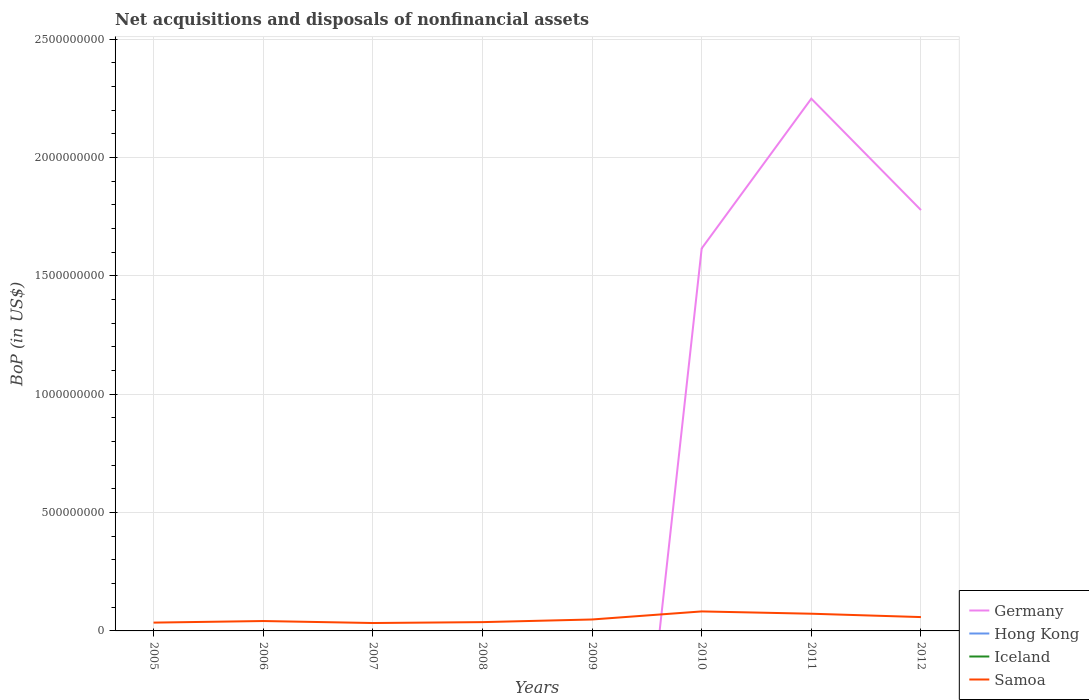How many different coloured lines are there?
Ensure brevity in your answer.  2. Does the line corresponding to Hong Kong intersect with the line corresponding to Germany?
Give a very brief answer. Yes. What is the total Balance of Payments in Samoa in the graph?
Give a very brief answer. -1.49e+07. What is the difference between the highest and the second highest Balance of Payments in Samoa?
Provide a short and direct response. 4.90e+07. How many lines are there?
Your answer should be compact. 2. How many years are there in the graph?
Give a very brief answer. 8. What is the difference between two consecutive major ticks on the Y-axis?
Your answer should be very brief. 5.00e+08. Does the graph contain any zero values?
Offer a terse response. Yes. Does the graph contain grids?
Give a very brief answer. Yes. Where does the legend appear in the graph?
Provide a short and direct response. Bottom right. How are the legend labels stacked?
Give a very brief answer. Vertical. What is the title of the graph?
Give a very brief answer. Net acquisitions and disposals of nonfinancial assets. Does "Belarus" appear as one of the legend labels in the graph?
Your response must be concise. No. What is the label or title of the X-axis?
Keep it short and to the point. Years. What is the label or title of the Y-axis?
Ensure brevity in your answer.  BoP (in US$). What is the BoP (in US$) in Hong Kong in 2005?
Give a very brief answer. 0. What is the BoP (in US$) of Iceland in 2005?
Your response must be concise. 0. What is the BoP (in US$) in Samoa in 2005?
Give a very brief answer. 3.51e+07. What is the BoP (in US$) in Iceland in 2006?
Offer a terse response. 0. What is the BoP (in US$) in Samoa in 2006?
Make the answer very short. 4.18e+07. What is the BoP (in US$) of Hong Kong in 2007?
Your response must be concise. 0. What is the BoP (in US$) of Samoa in 2007?
Provide a short and direct response. 3.34e+07. What is the BoP (in US$) of Germany in 2008?
Offer a terse response. 0. What is the BoP (in US$) in Hong Kong in 2008?
Your response must be concise. 0. What is the BoP (in US$) of Samoa in 2008?
Offer a terse response. 3.72e+07. What is the BoP (in US$) in Germany in 2009?
Your answer should be very brief. 0. What is the BoP (in US$) in Samoa in 2009?
Provide a short and direct response. 4.83e+07. What is the BoP (in US$) in Germany in 2010?
Provide a short and direct response. 1.62e+09. What is the BoP (in US$) of Iceland in 2010?
Make the answer very short. 0. What is the BoP (in US$) of Samoa in 2010?
Your response must be concise. 8.24e+07. What is the BoP (in US$) in Germany in 2011?
Provide a succinct answer. 2.25e+09. What is the BoP (in US$) in Iceland in 2011?
Your answer should be very brief. 0. What is the BoP (in US$) in Samoa in 2011?
Ensure brevity in your answer.  7.27e+07. What is the BoP (in US$) in Germany in 2012?
Keep it short and to the point. 1.78e+09. What is the BoP (in US$) in Samoa in 2012?
Make the answer very short. 5.84e+07. Across all years, what is the maximum BoP (in US$) of Germany?
Provide a succinct answer. 2.25e+09. Across all years, what is the maximum BoP (in US$) in Samoa?
Provide a short and direct response. 8.24e+07. Across all years, what is the minimum BoP (in US$) in Germany?
Make the answer very short. 0. Across all years, what is the minimum BoP (in US$) in Samoa?
Offer a terse response. 3.34e+07. What is the total BoP (in US$) in Germany in the graph?
Provide a succinct answer. 5.64e+09. What is the total BoP (in US$) in Iceland in the graph?
Your answer should be compact. 0. What is the total BoP (in US$) of Samoa in the graph?
Provide a short and direct response. 4.09e+08. What is the difference between the BoP (in US$) of Samoa in 2005 and that in 2006?
Provide a succinct answer. -6.65e+06. What is the difference between the BoP (in US$) in Samoa in 2005 and that in 2007?
Ensure brevity in your answer.  1.72e+06. What is the difference between the BoP (in US$) in Samoa in 2005 and that in 2008?
Keep it short and to the point. -2.09e+06. What is the difference between the BoP (in US$) in Samoa in 2005 and that in 2009?
Keep it short and to the point. -1.32e+07. What is the difference between the BoP (in US$) of Samoa in 2005 and that in 2010?
Make the answer very short. -4.73e+07. What is the difference between the BoP (in US$) in Samoa in 2005 and that in 2011?
Offer a very short reply. -3.76e+07. What is the difference between the BoP (in US$) of Samoa in 2005 and that in 2012?
Your answer should be compact. -2.33e+07. What is the difference between the BoP (in US$) of Samoa in 2006 and that in 2007?
Your answer should be compact. 8.37e+06. What is the difference between the BoP (in US$) in Samoa in 2006 and that in 2008?
Your answer should be compact. 4.56e+06. What is the difference between the BoP (in US$) in Samoa in 2006 and that in 2009?
Provide a short and direct response. -6.56e+06. What is the difference between the BoP (in US$) in Samoa in 2006 and that in 2010?
Make the answer very short. -4.06e+07. What is the difference between the BoP (in US$) in Samoa in 2006 and that in 2011?
Give a very brief answer. -3.09e+07. What is the difference between the BoP (in US$) of Samoa in 2006 and that in 2012?
Keep it short and to the point. -1.67e+07. What is the difference between the BoP (in US$) of Samoa in 2007 and that in 2008?
Your response must be concise. -3.81e+06. What is the difference between the BoP (in US$) in Samoa in 2007 and that in 2009?
Your answer should be compact. -1.49e+07. What is the difference between the BoP (in US$) in Samoa in 2007 and that in 2010?
Make the answer very short. -4.90e+07. What is the difference between the BoP (in US$) of Samoa in 2007 and that in 2011?
Keep it short and to the point. -3.93e+07. What is the difference between the BoP (in US$) of Samoa in 2007 and that in 2012?
Your answer should be compact. -2.51e+07. What is the difference between the BoP (in US$) of Samoa in 2008 and that in 2009?
Your response must be concise. -1.11e+07. What is the difference between the BoP (in US$) of Samoa in 2008 and that in 2010?
Provide a short and direct response. -4.52e+07. What is the difference between the BoP (in US$) in Samoa in 2008 and that in 2011?
Give a very brief answer. -3.55e+07. What is the difference between the BoP (in US$) in Samoa in 2008 and that in 2012?
Ensure brevity in your answer.  -2.13e+07. What is the difference between the BoP (in US$) in Samoa in 2009 and that in 2010?
Give a very brief answer. -3.41e+07. What is the difference between the BoP (in US$) of Samoa in 2009 and that in 2011?
Make the answer very short. -2.44e+07. What is the difference between the BoP (in US$) in Samoa in 2009 and that in 2012?
Ensure brevity in your answer.  -1.01e+07. What is the difference between the BoP (in US$) in Germany in 2010 and that in 2011?
Give a very brief answer. -6.33e+08. What is the difference between the BoP (in US$) in Samoa in 2010 and that in 2011?
Give a very brief answer. 9.68e+06. What is the difference between the BoP (in US$) in Germany in 2010 and that in 2012?
Keep it short and to the point. -1.62e+08. What is the difference between the BoP (in US$) in Samoa in 2010 and that in 2012?
Offer a terse response. 2.39e+07. What is the difference between the BoP (in US$) of Germany in 2011 and that in 2012?
Your answer should be very brief. 4.70e+08. What is the difference between the BoP (in US$) of Samoa in 2011 and that in 2012?
Make the answer very short. 1.42e+07. What is the difference between the BoP (in US$) of Germany in 2010 and the BoP (in US$) of Samoa in 2011?
Ensure brevity in your answer.  1.54e+09. What is the difference between the BoP (in US$) in Germany in 2010 and the BoP (in US$) in Samoa in 2012?
Your answer should be very brief. 1.56e+09. What is the difference between the BoP (in US$) in Germany in 2011 and the BoP (in US$) in Samoa in 2012?
Provide a succinct answer. 2.19e+09. What is the average BoP (in US$) of Germany per year?
Your answer should be compact. 7.05e+08. What is the average BoP (in US$) of Hong Kong per year?
Your answer should be very brief. 0. What is the average BoP (in US$) in Iceland per year?
Provide a short and direct response. 0. What is the average BoP (in US$) of Samoa per year?
Your response must be concise. 5.12e+07. In the year 2010, what is the difference between the BoP (in US$) of Germany and BoP (in US$) of Samoa?
Ensure brevity in your answer.  1.53e+09. In the year 2011, what is the difference between the BoP (in US$) in Germany and BoP (in US$) in Samoa?
Offer a terse response. 2.18e+09. In the year 2012, what is the difference between the BoP (in US$) of Germany and BoP (in US$) of Samoa?
Provide a short and direct response. 1.72e+09. What is the ratio of the BoP (in US$) of Samoa in 2005 to that in 2006?
Your answer should be very brief. 0.84. What is the ratio of the BoP (in US$) in Samoa in 2005 to that in 2007?
Your answer should be very brief. 1.05. What is the ratio of the BoP (in US$) in Samoa in 2005 to that in 2008?
Offer a terse response. 0.94. What is the ratio of the BoP (in US$) of Samoa in 2005 to that in 2009?
Give a very brief answer. 0.73. What is the ratio of the BoP (in US$) of Samoa in 2005 to that in 2010?
Offer a very short reply. 0.43. What is the ratio of the BoP (in US$) of Samoa in 2005 to that in 2011?
Your answer should be very brief. 0.48. What is the ratio of the BoP (in US$) of Samoa in 2005 to that in 2012?
Give a very brief answer. 0.6. What is the ratio of the BoP (in US$) of Samoa in 2006 to that in 2007?
Provide a short and direct response. 1.25. What is the ratio of the BoP (in US$) of Samoa in 2006 to that in 2008?
Offer a very short reply. 1.12. What is the ratio of the BoP (in US$) in Samoa in 2006 to that in 2009?
Make the answer very short. 0.86. What is the ratio of the BoP (in US$) in Samoa in 2006 to that in 2010?
Ensure brevity in your answer.  0.51. What is the ratio of the BoP (in US$) of Samoa in 2006 to that in 2011?
Provide a succinct answer. 0.57. What is the ratio of the BoP (in US$) of Samoa in 2006 to that in 2012?
Make the answer very short. 0.71. What is the ratio of the BoP (in US$) in Samoa in 2007 to that in 2008?
Your answer should be very brief. 0.9. What is the ratio of the BoP (in US$) of Samoa in 2007 to that in 2009?
Your answer should be very brief. 0.69. What is the ratio of the BoP (in US$) in Samoa in 2007 to that in 2010?
Give a very brief answer. 0.41. What is the ratio of the BoP (in US$) of Samoa in 2007 to that in 2011?
Give a very brief answer. 0.46. What is the ratio of the BoP (in US$) of Samoa in 2007 to that in 2012?
Your answer should be very brief. 0.57. What is the ratio of the BoP (in US$) of Samoa in 2008 to that in 2009?
Offer a very short reply. 0.77. What is the ratio of the BoP (in US$) of Samoa in 2008 to that in 2010?
Offer a terse response. 0.45. What is the ratio of the BoP (in US$) of Samoa in 2008 to that in 2011?
Your answer should be very brief. 0.51. What is the ratio of the BoP (in US$) in Samoa in 2008 to that in 2012?
Provide a succinct answer. 0.64. What is the ratio of the BoP (in US$) in Samoa in 2009 to that in 2010?
Give a very brief answer. 0.59. What is the ratio of the BoP (in US$) in Samoa in 2009 to that in 2011?
Your answer should be very brief. 0.66. What is the ratio of the BoP (in US$) of Samoa in 2009 to that in 2012?
Provide a succinct answer. 0.83. What is the ratio of the BoP (in US$) of Germany in 2010 to that in 2011?
Your response must be concise. 0.72. What is the ratio of the BoP (in US$) of Samoa in 2010 to that in 2011?
Your response must be concise. 1.13. What is the ratio of the BoP (in US$) in Germany in 2010 to that in 2012?
Keep it short and to the point. 0.91. What is the ratio of the BoP (in US$) in Samoa in 2010 to that in 2012?
Make the answer very short. 1.41. What is the ratio of the BoP (in US$) of Germany in 2011 to that in 2012?
Your answer should be compact. 1.26. What is the ratio of the BoP (in US$) of Samoa in 2011 to that in 2012?
Keep it short and to the point. 1.24. What is the difference between the highest and the second highest BoP (in US$) of Germany?
Your response must be concise. 4.70e+08. What is the difference between the highest and the second highest BoP (in US$) of Samoa?
Provide a short and direct response. 9.68e+06. What is the difference between the highest and the lowest BoP (in US$) of Germany?
Ensure brevity in your answer.  2.25e+09. What is the difference between the highest and the lowest BoP (in US$) of Samoa?
Provide a succinct answer. 4.90e+07. 